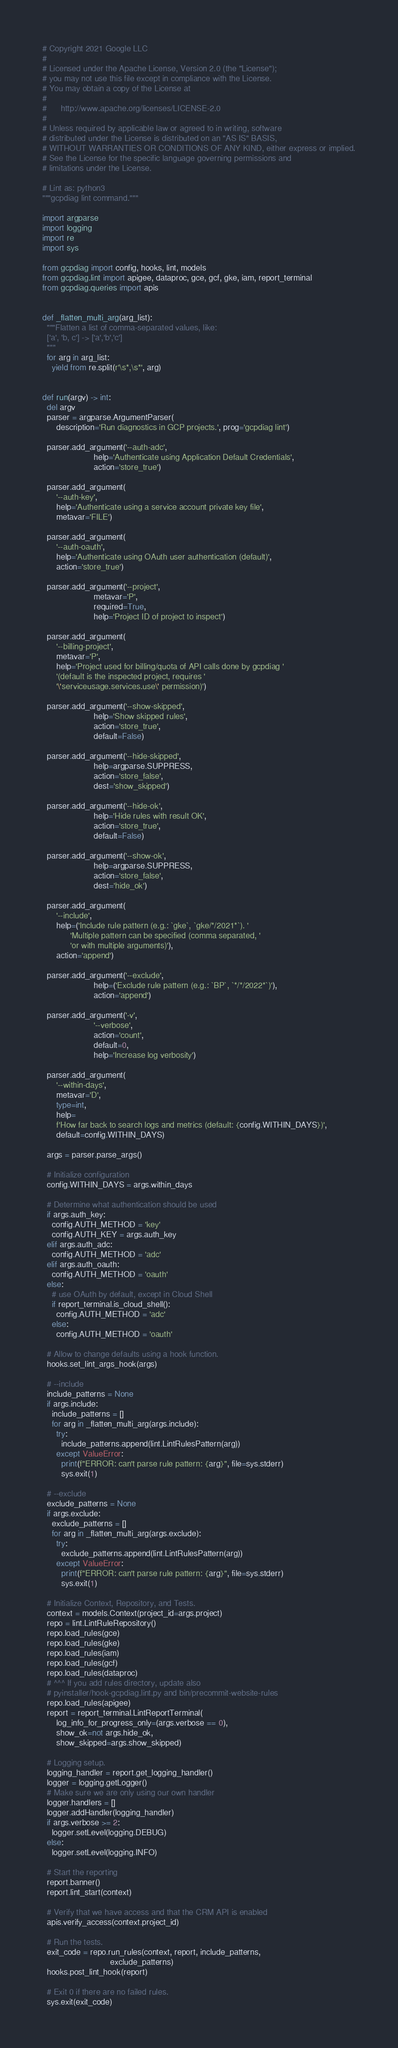<code> <loc_0><loc_0><loc_500><loc_500><_Python_># Copyright 2021 Google LLC
#
# Licensed under the Apache License, Version 2.0 (the "License");
# you may not use this file except in compliance with the License.
# You may obtain a copy of the License at
#
#      http://www.apache.org/licenses/LICENSE-2.0
#
# Unless required by applicable law or agreed to in writing, software
# distributed under the License is distributed on an "AS IS" BASIS,
# WITHOUT WARRANTIES OR CONDITIONS OF ANY KIND, either express or implied.
# See the License for the specific language governing permissions and
# limitations under the License.

# Lint as: python3
"""gcpdiag lint command."""

import argparse
import logging
import re
import sys

from gcpdiag import config, hooks, lint, models
from gcpdiag.lint import apigee, dataproc, gce, gcf, gke, iam, report_terminal
from gcpdiag.queries import apis


def _flatten_multi_arg(arg_list):
  """Flatten a list of comma-separated values, like:
  ['a', 'b, c'] -> ['a','b','c']
  """
  for arg in arg_list:
    yield from re.split(r'\s*,\s*', arg)


def run(argv) -> int:
  del argv
  parser = argparse.ArgumentParser(
      description='Run diagnostics in GCP projects.', prog='gcpdiag lint')

  parser.add_argument('--auth-adc',
                      help='Authenticate using Application Default Credentials',
                      action='store_true')

  parser.add_argument(
      '--auth-key',
      help='Authenticate using a service account private key file',
      metavar='FILE')

  parser.add_argument(
      '--auth-oauth',
      help='Authenticate using OAuth user authentication (default)',
      action='store_true')

  parser.add_argument('--project',
                      metavar='P',
                      required=True,
                      help='Project ID of project to inspect')

  parser.add_argument(
      '--billing-project',
      metavar='P',
      help='Project used for billing/quota of API calls done by gcpdiag '
      '(default is the inspected project, requires '
      '\'serviceusage.services.use\' permission)')

  parser.add_argument('--show-skipped',
                      help='Show skipped rules',
                      action='store_true',
                      default=False)

  parser.add_argument('--hide-skipped',
                      help=argparse.SUPPRESS,
                      action='store_false',
                      dest='show_skipped')

  parser.add_argument('--hide-ok',
                      help='Hide rules with result OK',
                      action='store_true',
                      default=False)

  parser.add_argument('--show-ok',
                      help=argparse.SUPPRESS,
                      action='store_false',
                      dest='hide_ok')

  parser.add_argument(
      '--include',
      help=('Include rule pattern (e.g.: `gke`, `gke/*/2021*`). '
            'Multiple pattern can be specified (comma separated, '
            'or with multiple arguments)'),
      action='append')

  parser.add_argument('--exclude',
                      help=('Exclude rule pattern (e.g.: `BP`, `*/*/2022*`)'),
                      action='append')

  parser.add_argument('-v',
                      '--verbose',
                      action='count',
                      default=0,
                      help='Increase log verbosity')

  parser.add_argument(
      '--within-days',
      metavar='D',
      type=int,
      help=
      f'How far back to search logs and metrics (default: {config.WITHIN_DAYS})',
      default=config.WITHIN_DAYS)

  args = parser.parse_args()

  # Initialize configuration
  config.WITHIN_DAYS = args.within_days

  # Determine what authentication should be used
  if args.auth_key:
    config.AUTH_METHOD = 'key'
    config.AUTH_KEY = args.auth_key
  elif args.auth_adc:
    config.AUTH_METHOD = 'adc'
  elif args.auth_oauth:
    config.AUTH_METHOD = 'oauth'
  else:
    # use OAuth by default, except in Cloud Shell
    if report_terminal.is_cloud_shell():
      config.AUTH_METHOD = 'adc'
    else:
      config.AUTH_METHOD = 'oauth'

  # Allow to change defaults using a hook function.
  hooks.set_lint_args_hook(args)

  # --include
  include_patterns = None
  if args.include:
    include_patterns = []
    for arg in _flatten_multi_arg(args.include):
      try:
        include_patterns.append(lint.LintRulesPattern(arg))
      except ValueError:
        print(f"ERROR: can't parse rule pattern: {arg}", file=sys.stderr)
        sys.exit(1)

  # --exclude
  exclude_patterns = None
  if args.exclude:
    exclude_patterns = []
    for arg in _flatten_multi_arg(args.exclude):
      try:
        exclude_patterns.append(lint.LintRulesPattern(arg))
      except ValueError:
        print(f"ERROR: can't parse rule pattern: {arg}", file=sys.stderr)
        sys.exit(1)

  # Initialize Context, Repository, and Tests.
  context = models.Context(project_id=args.project)
  repo = lint.LintRuleRepository()
  repo.load_rules(gce)
  repo.load_rules(gke)
  repo.load_rules(iam)
  repo.load_rules(gcf)
  repo.load_rules(dataproc)
  # ^^^ If you add rules directory, update also
  # pyinstaller/hook-gcpdiag.lint.py and bin/precommit-website-rules
  repo.load_rules(apigee)
  report = report_terminal.LintReportTerminal(
      log_info_for_progress_only=(args.verbose == 0),
      show_ok=not args.hide_ok,
      show_skipped=args.show_skipped)

  # Logging setup.
  logging_handler = report.get_logging_handler()
  logger = logging.getLogger()
  # Make sure we are only using our own handler
  logger.handlers = []
  logger.addHandler(logging_handler)
  if args.verbose >= 2:
    logger.setLevel(logging.DEBUG)
  else:
    logger.setLevel(logging.INFO)

  # Start the reporting
  report.banner()
  report.lint_start(context)

  # Verify that we have access and that the CRM API is enabled
  apis.verify_access(context.project_id)

  # Run the tests.
  exit_code = repo.run_rules(context, report, include_patterns,
                             exclude_patterns)
  hooks.post_lint_hook(report)

  # Exit 0 if there are no failed rules.
  sys.exit(exit_code)
</code> 